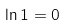<formula> <loc_0><loc_0><loc_500><loc_500>\ln 1 = 0</formula> 